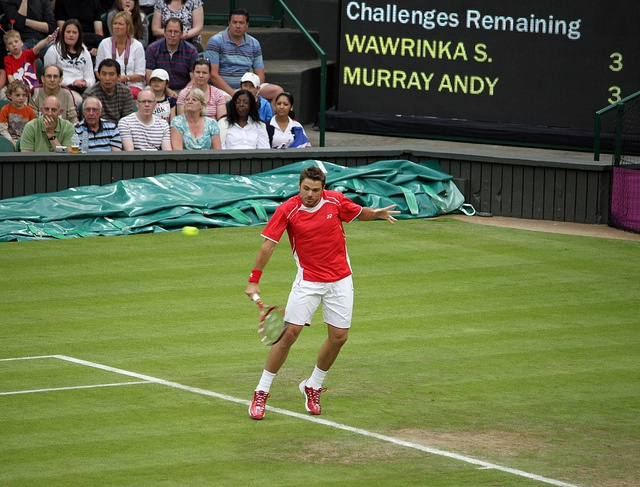Describe the objects in this image and their specific colors. I can see people in black, gray, brown, and darkgray tones, people in black, olive, lightgray, and brown tones, people in black, gray, and brown tones, people in black, gray, darkgreen, and olive tones, and people in black, lavender, darkgray, and gray tones in this image. 